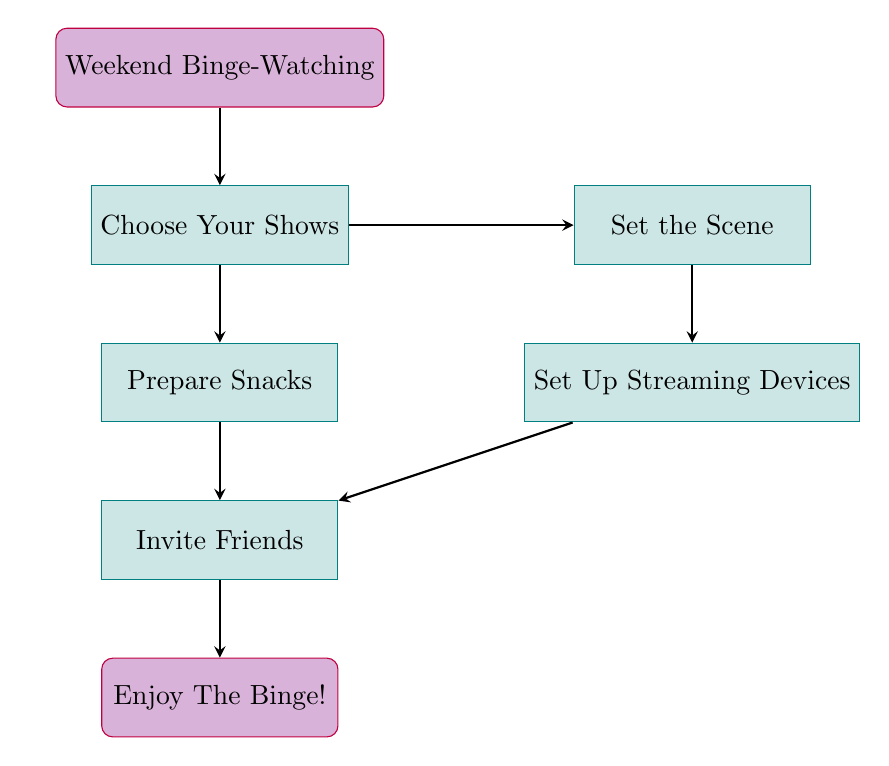What is the starting point of the flow chart? The flow chart begins with the node labeled "Weekend Binge-Watching," which serves as the foundation for the subsequent steps.
Answer: Weekend Binge-Watching How many main steps are there in the checklist? The flow chart displays six main steps, which are the nodes leading from the starting point to the final action of enjoying the binge.
Answer: Six What is the first step after choosing your shows? After "Choose Your Shows," the next step is "Set the Scene," which indicates the actions to prepare the watching environment.
Answer: Set the Scene Which step involves inviting friends? The step that involves inviting friends is labeled "Invite Friends." This indicates when friends are contacted to join the binge-watching session.
Answer: Invite Friends What task follows arranging comfy seating? The task that follows "Arrange comfy seating" is "Adjust room lighting," indicating the sequence of actions taken to create a comfortable environment.
Answer: Adjust room lighting Which two steps occur before enjoying the binge? Before enjoying the binge, "Invite Friends" and "Prepare Snacks" must be completed, illustrating the preparation required before starting.
Answer: Invite Friends and Prepare Snacks How does the flow chart indicate the completion of binge-watching? The flow chart indicates completion by reaching the final node labeled "Enjoy The Binge!," which signifies that all previous preparations are done.
Answer: Enjoy The Binge! What relationship exists between "Prepare Snacks" and "Invite Friends"? "Prepare Snacks" leads to "Invite Friends," demonstrating that once snacks are prepared, the next step is to coordinate with friends to join for the binge-watching session.
Answer: Prepare Snacks leads to Invite Friends 